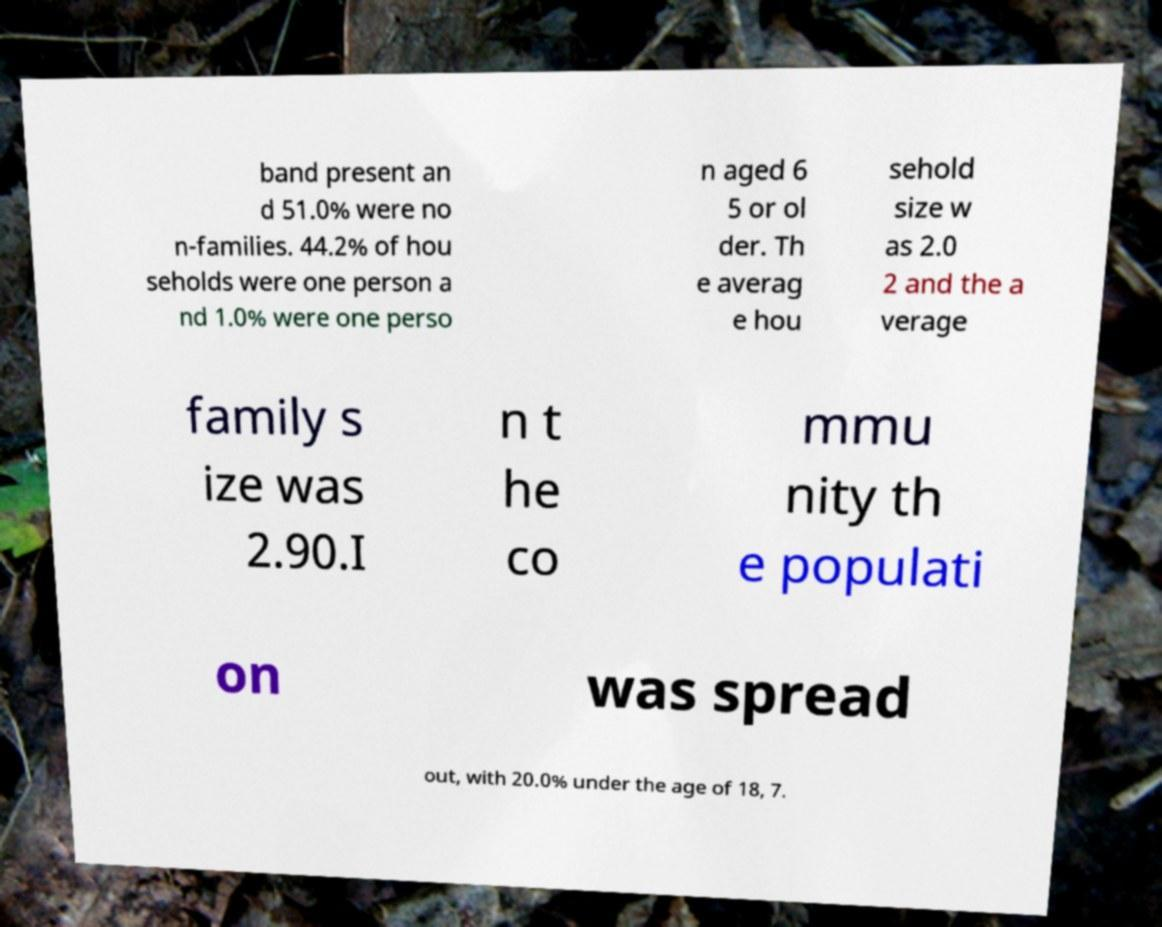There's text embedded in this image that I need extracted. Can you transcribe it verbatim? band present an d 51.0% were no n-families. 44.2% of hou seholds were one person a nd 1.0% were one perso n aged 6 5 or ol der. Th e averag e hou sehold size w as 2.0 2 and the a verage family s ize was 2.90.I n t he co mmu nity th e populati on was spread out, with 20.0% under the age of 18, 7. 